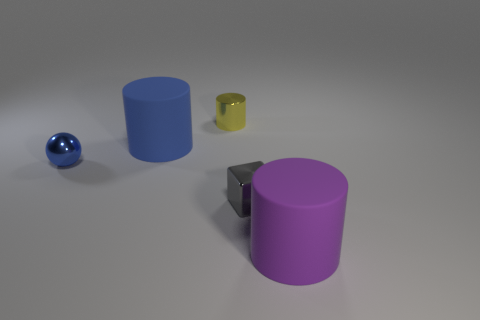How big is the object behind the blue matte cylinder?
Offer a terse response. Small. Are there an equal number of rubber things that are behind the small blue metal sphere and gray metallic things in front of the blue cylinder?
Your answer should be very brief. Yes. What is the color of the large thing behind the blue shiny object that is in front of the large matte cylinder behind the gray thing?
Your response must be concise. Blue. How many objects are to the left of the yellow cylinder and behind the sphere?
Provide a succinct answer. 1. Is the color of the large cylinder that is in front of the tiny gray shiny object the same as the large cylinder behind the blue ball?
Ensure brevity in your answer.  No. Are there any other things that have the same material as the purple cylinder?
Give a very brief answer. Yes. There is a purple rubber thing that is the same shape as the yellow shiny thing; what size is it?
Your answer should be very brief. Large. Are there any tiny blue shiny objects in front of the large purple cylinder?
Your answer should be very brief. No. Are there an equal number of blocks right of the cube and purple things?
Keep it short and to the point. No. There is a matte cylinder to the left of the rubber cylinder that is to the right of the blue rubber cylinder; are there any tiny blue metallic objects that are in front of it?
Keep it short and to the point. Yes. 